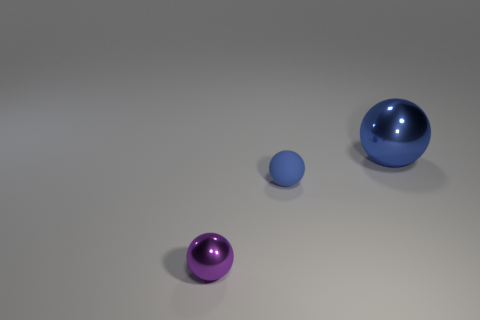Imagine these objects were part of a larger setting; what kind of environment could they belong to? If these objects were part of a larger setting, they could belong to a modern art installation, symbolizing simplicity and form. The clean background and the minimalist aspect of the objects suggest a setting that values aesthetics and design, perhaps a gallery or a conceptual space that encourages reflection on the intrinsic beauty of shapes and materials. 